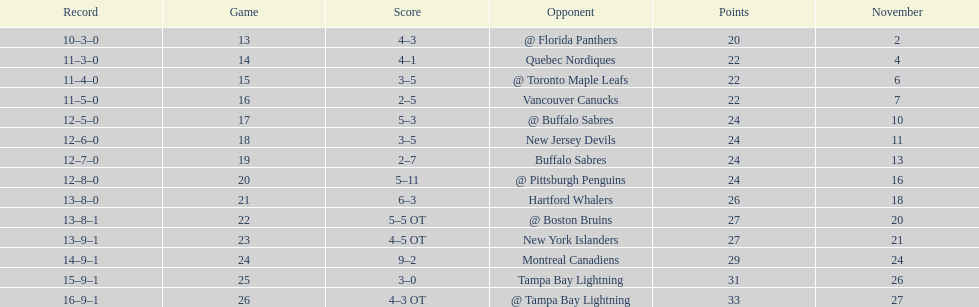What other team had the closest amount of wins? New York Islanders. 